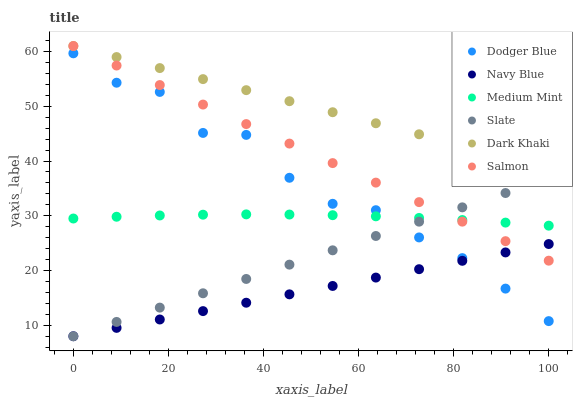Does Navy Blue have the minimum area under the curve?
Answer yes or no. Yes. Does Dark Khaki have the maximum area under the curve?
Answer yes or no. Yes. Does Slate have the minimum area under the curve?
Answer yes or no. No. Does Slate have the maximum area under the curve?
Answer yes or no. No. Is Slate the smoothest?
Answer yes or no. Yes. Is Dodger Blue the roughest?
Answer yes or no. Yes. Is Navy Blue the smoothest?
Answer yes or no. No. Is Navy Blue the roughest?
Answer yes or no. No. Does Navy Blue have the lowest value?
Answer yes or no. Yes. Does Salmon have the lowest value?
Answer yes or no. No. Does Dark Khaki have the highest value?
Answer yes or no. Yes. Does Slate have the highest value?
Answer yes or no. No. Is Navy Blue less than Dark Khaki?
Answer yes or no. Yes. Is Dark Khaki greater than Medium Mint?
Answer yes or no. Yes. Does Medium Mint intersect Dodger Blue?
Answer yes or no. Yes. Is Medium Mint less than Dodger Blue?
Answer yes or no. No. Is Medium Mint greater than Dodger Blue?
Answer yes or no. No. Does Navy Blue intersect Dark Khaki?
Answer yes or no. No. 